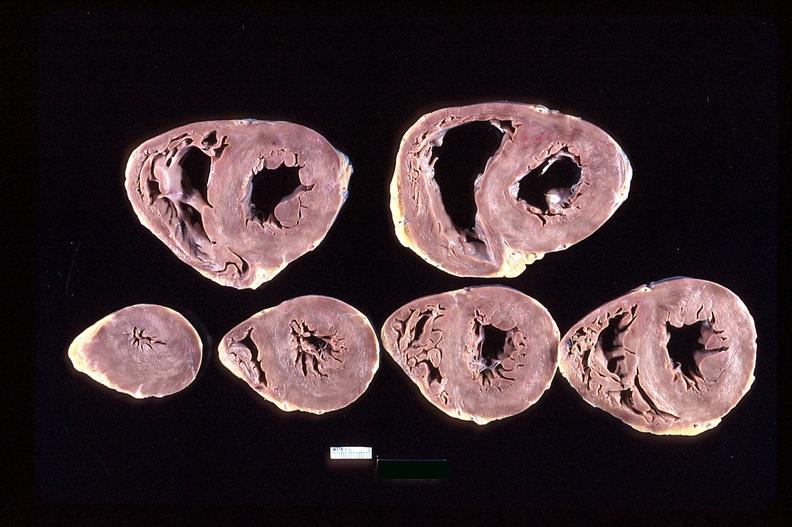s this photo of infant from head to toe present?
Answer the question using a single word or phrase. No 